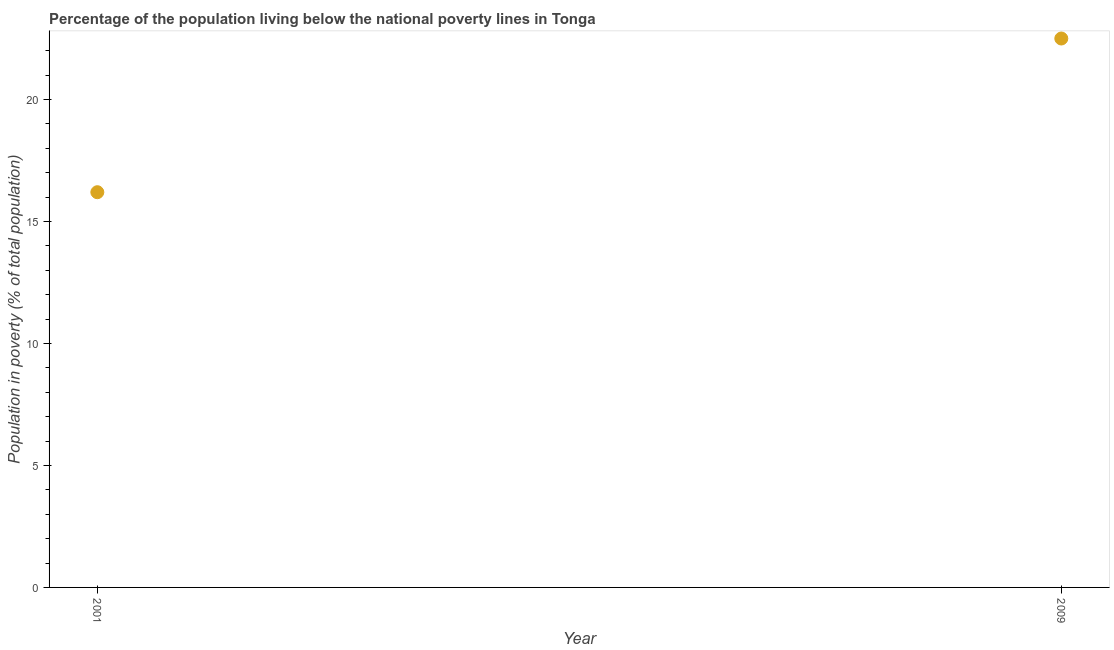In which year was the percentage of population living below poverty line maximum?
Offer a terse response. 2009. In which year was the percentage of population living below poverty line minimum?
Provide a short and direct response. 2001. What is the sum of the percentage of population living below poverty line?
Offer a terse response. 38.7. What is the difference between the percentage of population living below poverty line in 2001 and 2009?
Ensure brevity in your answer.  -6.3. What is the average percentage of population living below poverty line per year?
Provide a succinct answer. 19.35. What is the median percentage of population living below poverty line?
Keep it short and to the point. 19.35. In how many years, is the percentage of population living below poverty line greater than 20 %?
Give a very brief answer. 1. What is the ratio of the percentage of population living below poverty line in 2001 to that in 2009?
Make the answer very short. 0.72. In how many years, is the percentage of population living below poverty line greater than the average percentage of population living below poverty line taken over all years?
Keep it short and to the point. 1. Does the graph contain any zero values?
Your answer should be compact. No. Does the graph contain grids?
Make the answer very short. No. What is the title of the graph?
Give a very brief answer. Percentage of the population living below the national poverty lines in Tonga. What is the label or title of the Y-axis?
Offer a terse response. Population in poverty (% of total population). What is the Population in poverty (% of total population) in 2009?
Provide a short and direct response. 22.5. What is the ratio of the Population in poverty (% of total population) in 2001 to that in 2009?
Make the answer very short. 0.72. 